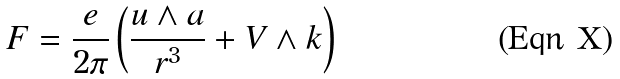<formula> <loc_0><loc_0><loc_500><loc_500>F = \frac { e } { 2 \pi } \left ( \frac { u \wedge a } { r ^ { 3 } } + V \wedge k \right )</formula> 